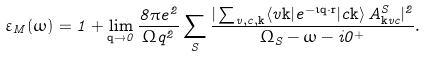<formula> <loc_0><loc_0><loc_500><loc_500>\varepsilon _ { M } ( \omega ) = 1 + \lim _ { \mathbf q \to 0 } \frac { 8 \pi e ^ { 2 } } { \Omega q ^ { 2 } } \sum _ { S } \frac { | \sum _ { v , c , \mathbf k } \langle v \mathbf k | e ^ { - \imath \mathbf q \cdot \mathbf r } | c \mathbf k \rangle \, A ^ { S } _ { \mathbf k v c } | ^ { 2 } } { \Omega _ { S } - \omega - i 0 ^ { + } } .</formula> 